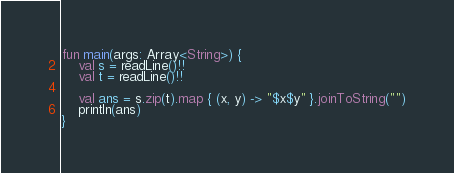<code> <loc_0><loc_0><loc_500><loc_500><_Kotlin_>fun main(args: Array<String>) {
    val s = readLine()!!
    val t = readLine()!!

    val ans = s.zip(t).map { (x, y) -> "$x$y" }.joinToString("")
    println(ans)
}</code> 